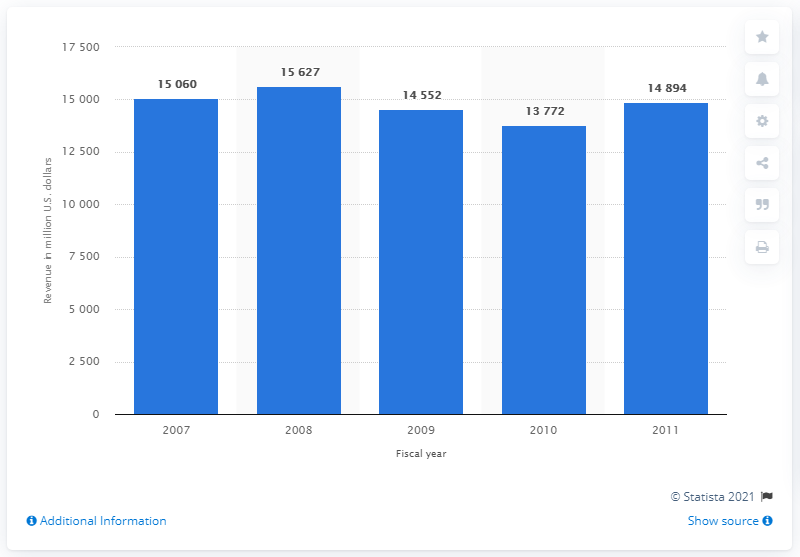Identify some key points in this picture. In 2010, the revenue of Qantas Group was 1,3772. The revenue of Qantas Group was first reported in 2007. 